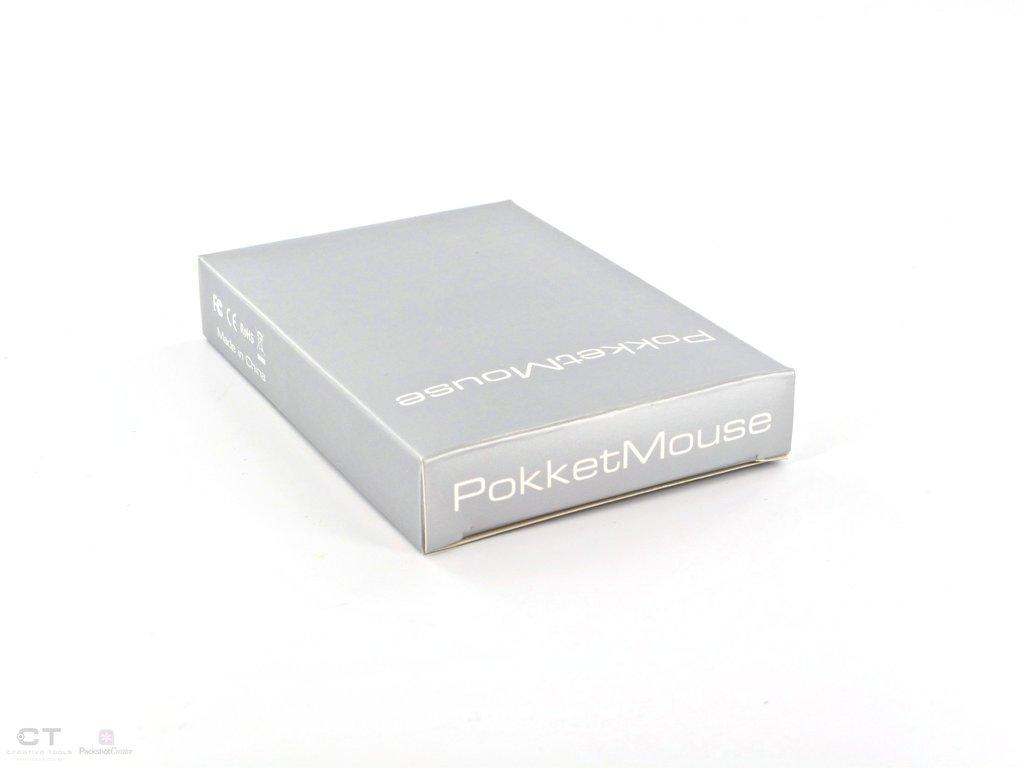What object is present in the image? There is a box in the image. What color is the box? The box is ash colored. What is written on the box? The name "Pocket Mouse" is written on the box. What is the surface beneath the box? The box is on a white surface. What type of music can be heard coming from the box in the image? There is no indication in the image that the box is producing music, so it cannot be determined from the picture. 